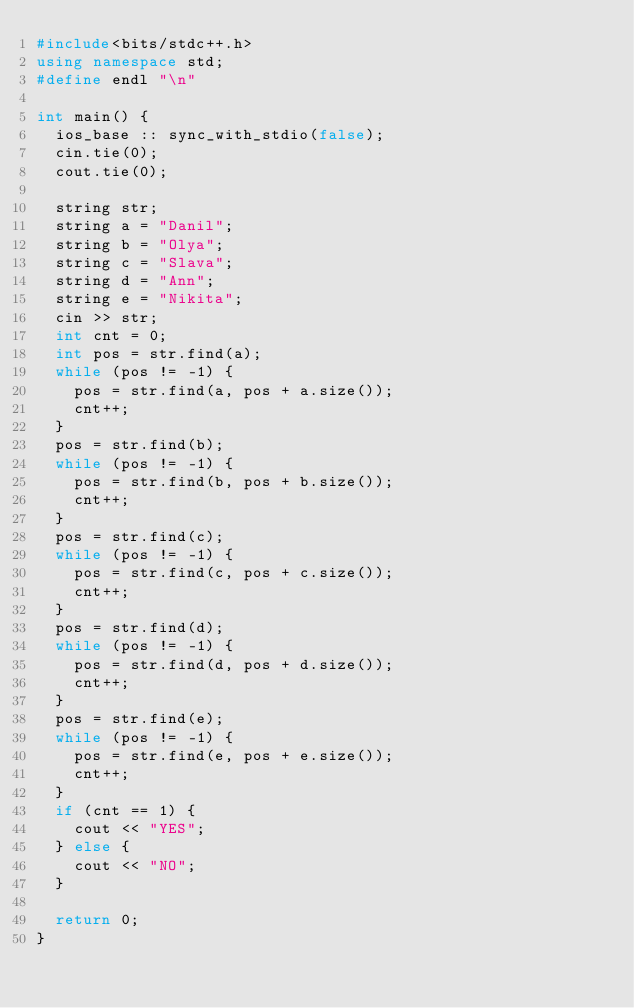<code> <loc_0><loc_0><loc_500><loc_500><_C++_>#include<bits/stdc++.h>
using namespace std;
#define endl "\n"

int main() {
	ios_base :: sync_with_stdio(false);
	cin.tie(0);
	cout.tie(0);

	string str;
	string a = "Danil";
	string b = "Olya";
	string c = "Slava";
	string d = "Ann";
	string e = "Nikita";
	cin >> str;
	int cnt = 0;
	int pos = str.find(a);
	while (pos != -1) {
		pos = str.find(a, pos + a.size());
		cnt++;
	}
	pos = str.find(b);
	while (pos != -1) {
		pos = str.find(b, pos + b.size());
		cnt++;
	}
	pos = str.find(c);
	while (pos != -1) {
		pos = str.find(c, pos + c.size());
		cnt++;
	}
	pos = str.find(d);
	while (pos != -1) {
		pos = str.find(d, pos + d.size());
		cnt++;
	}
	pos = str.find(e);
	while (pos != -1) {
		pos = str.find(e, pos + e.size());
		cnt++;
	}
	if (cnt == 1) {
		cout << "YES";
	} else {
		cout << "NO";
	}

	return 0;
}</code> 